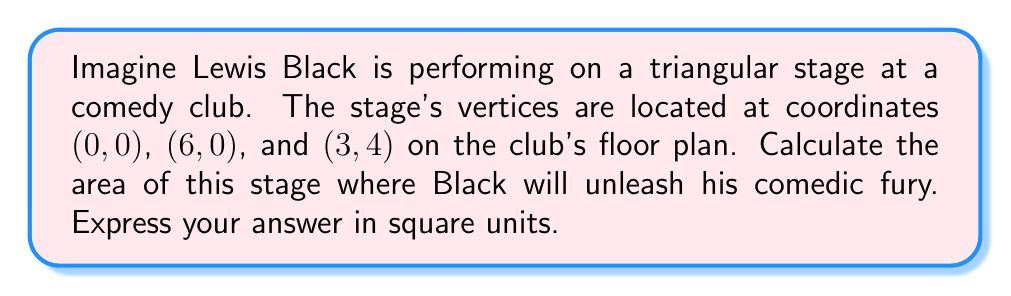Teach me how to tackle this problem. To find the area of the triangular stage, we can use the formula for the area of a triangle given the coordinates of its vertices:

$$ A = \frac{1}{2}|x_1(y_2 - y_3) + x_2(y_3 - y_1) + x_3(y_1 - y_2)| $$

Where $(x_1, y_1)$, $(x_2, y_2)$, and $(x_3, y_3)$ are the coordinates of the three vertices.

Let's assign our coordinates:
$(x_1, y_1) = (0, 0)$
$(x_2, y_2) = (6, 0)$
$(x_3, y_3) = (3, 4)$

Now, let's substitute these into our formula:

$$ A = \frac{1}{2}|0(0 - 4) + 6(4 - 0) + 3(0 - 0)| $$

Simplifying:
$$ A = \frac{1}{2}|0 + 24 + 0| $$
$$ A = \frac{1}{2}|24| $$
$$ A = \frac{1}{2}(24) $$
$$ A = 12 $$

Therefore, the area of the triangular stage is 12 square units.

[asy]
unitsize(1cm);
draw((0,0)--(6,0)--(3,4)--cycle);
label("(0,0)", (0,0), SW);
label("(6,0)", (6,0), SE);
label("(3,4)", (3,4), N);
label("Lewis Black", (3,1.5), E);
[/asy]
Answer: 12 square units 